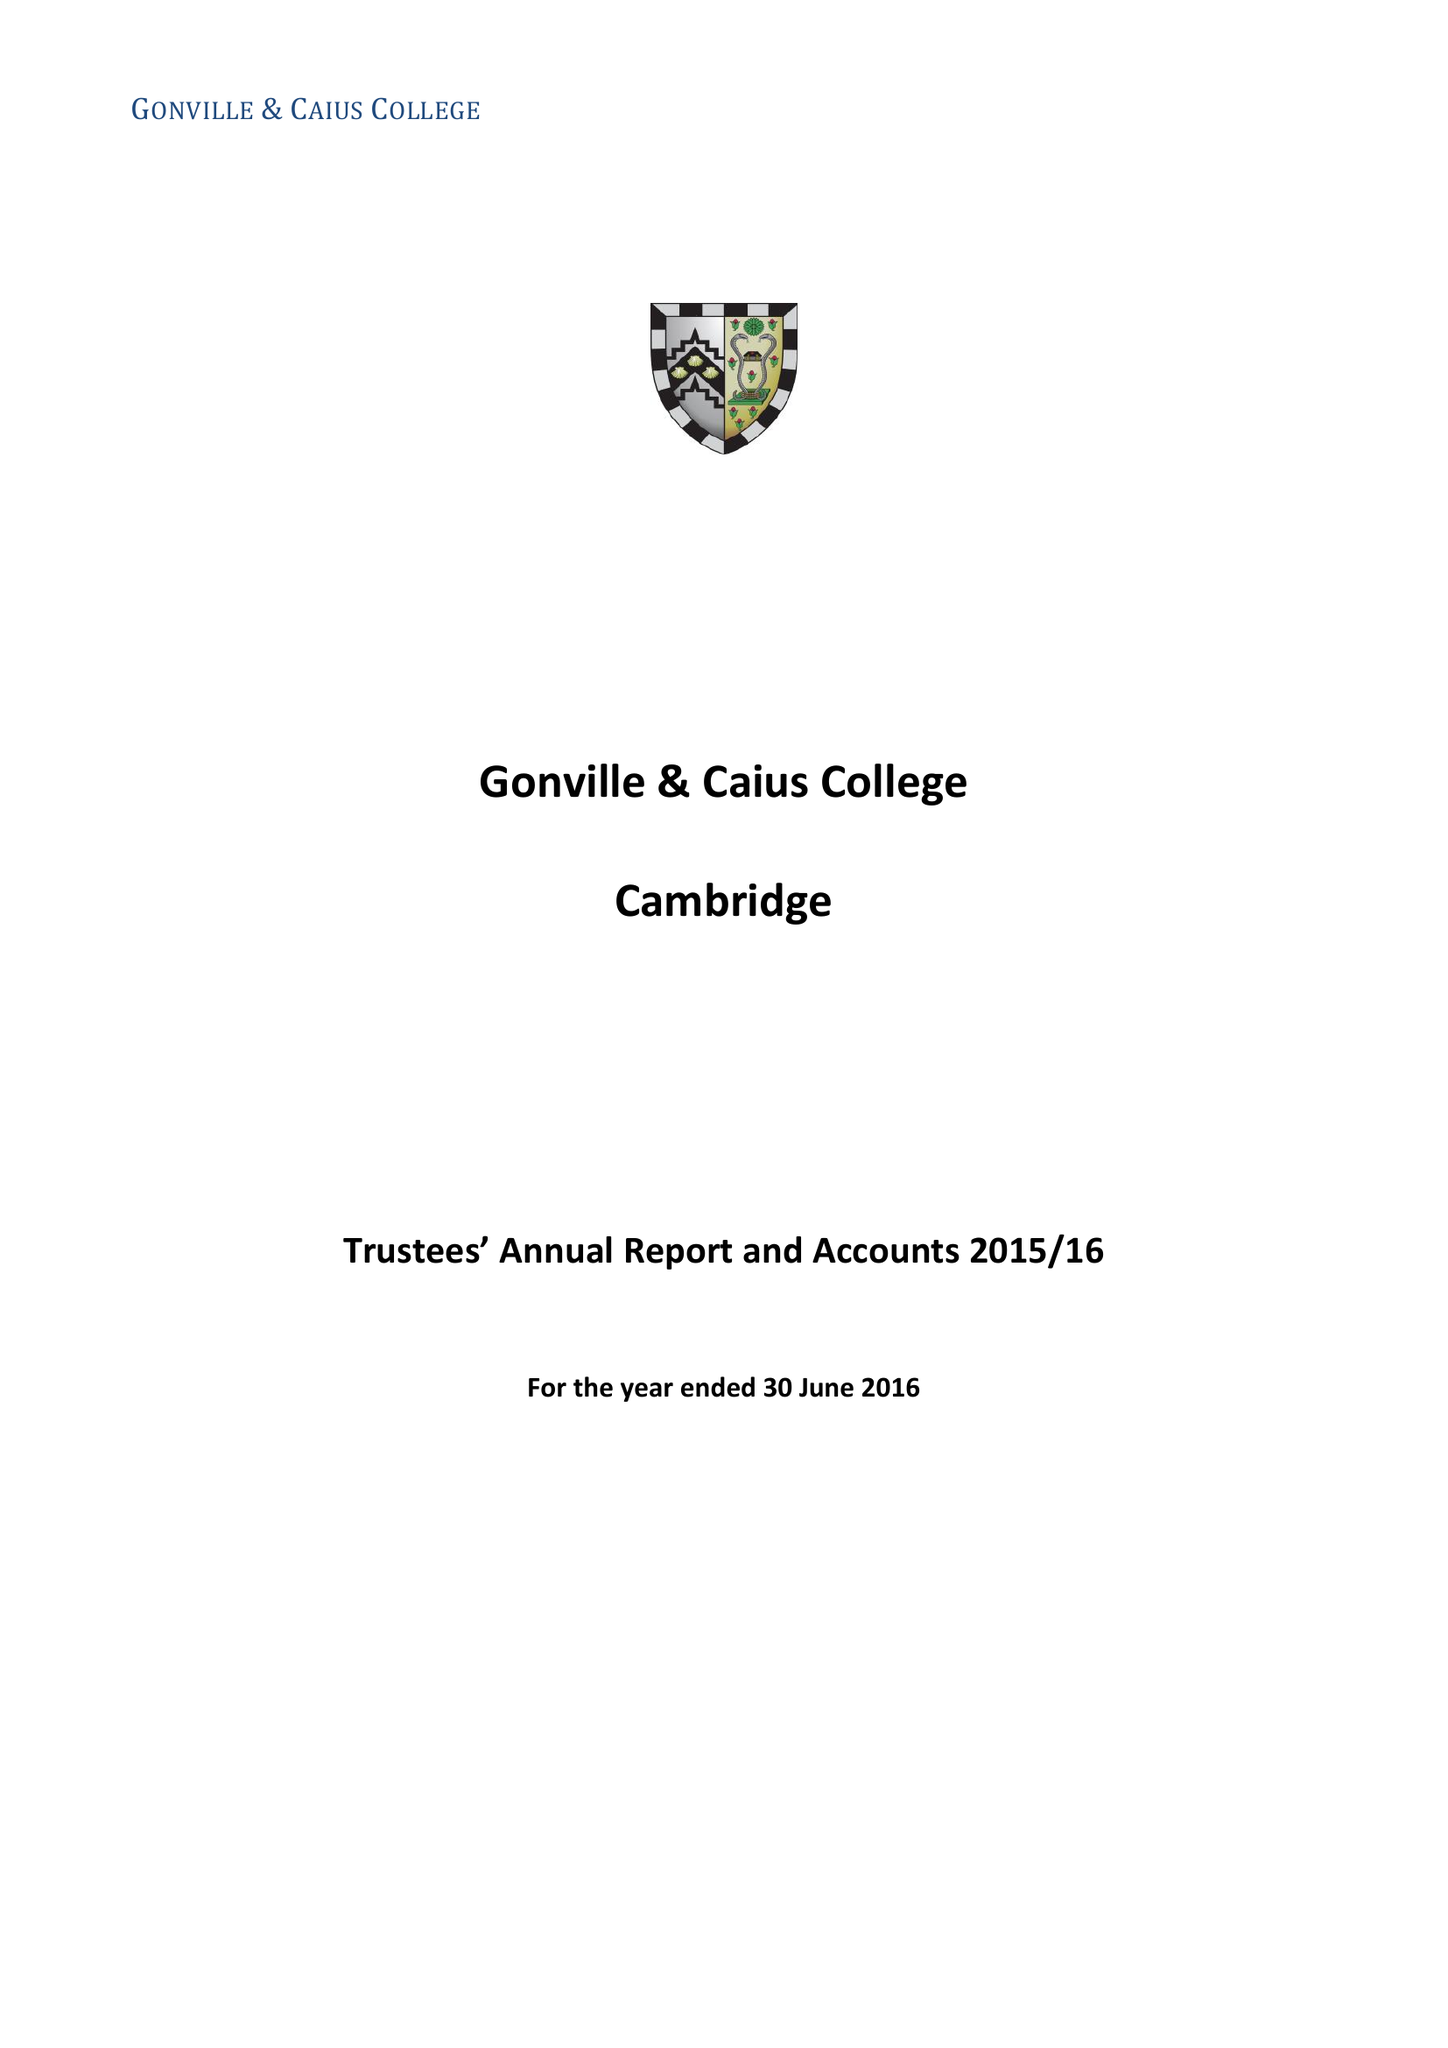What is the value for the report_date?
Answer the question using a single word or phrase. 2016-06-30 